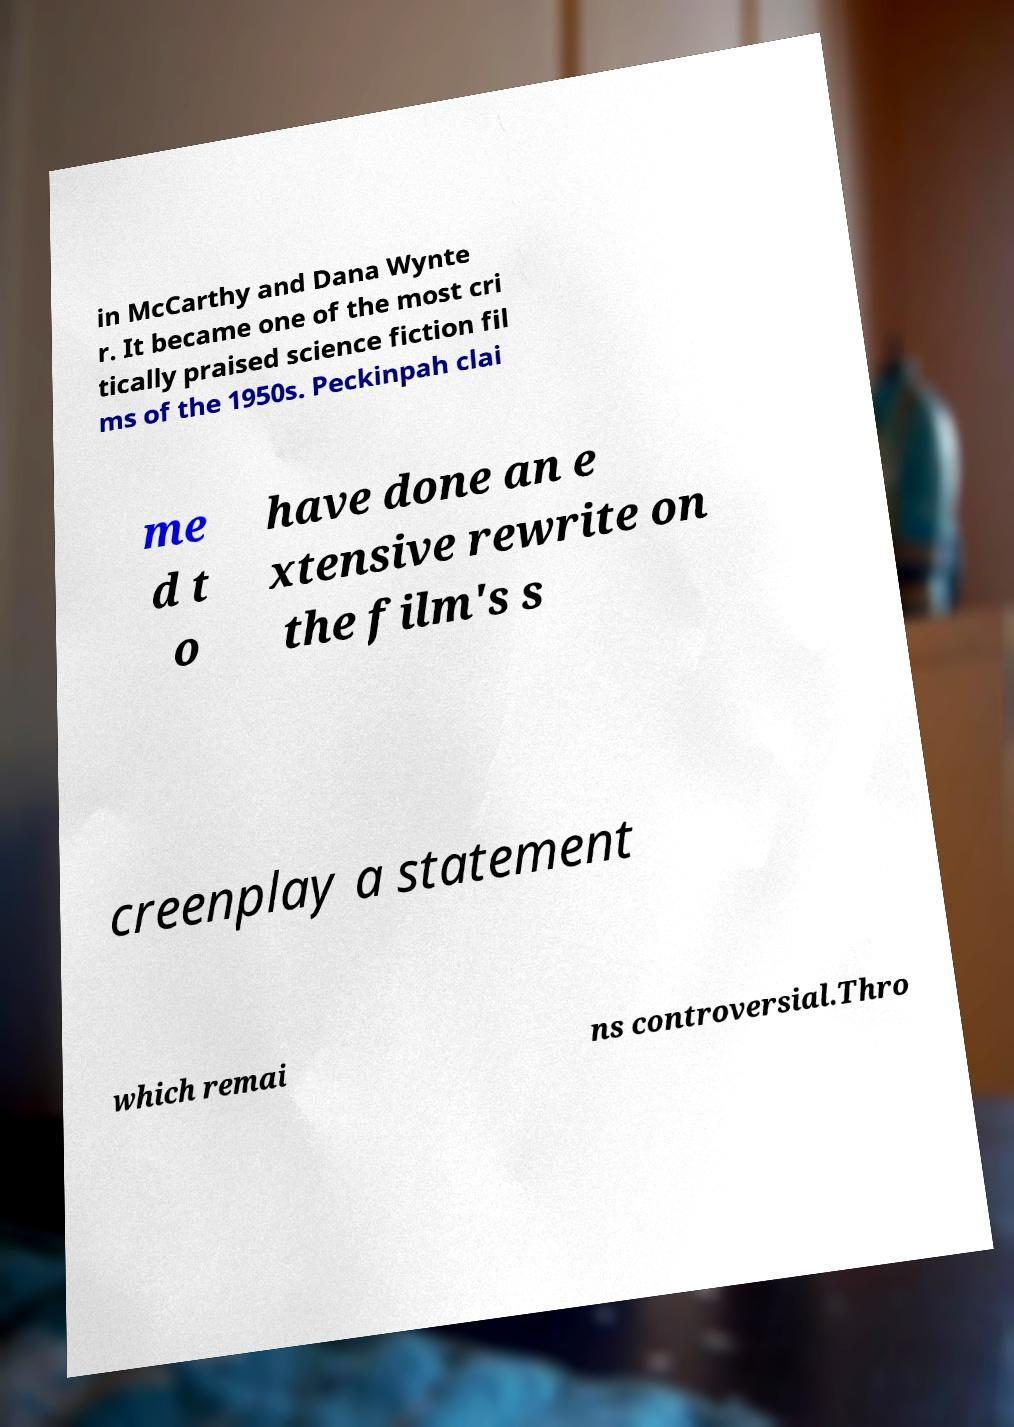Could you extract and type out the text from this image? in McCarthy and Dana Wynte r. It became one of the most cri tically praised science fiction fil ms of the 1950s. Peckinpah clai me d t o have done an e xtensive rewrite on the film's s creenplay a statement which remai ns controversial.Thro 